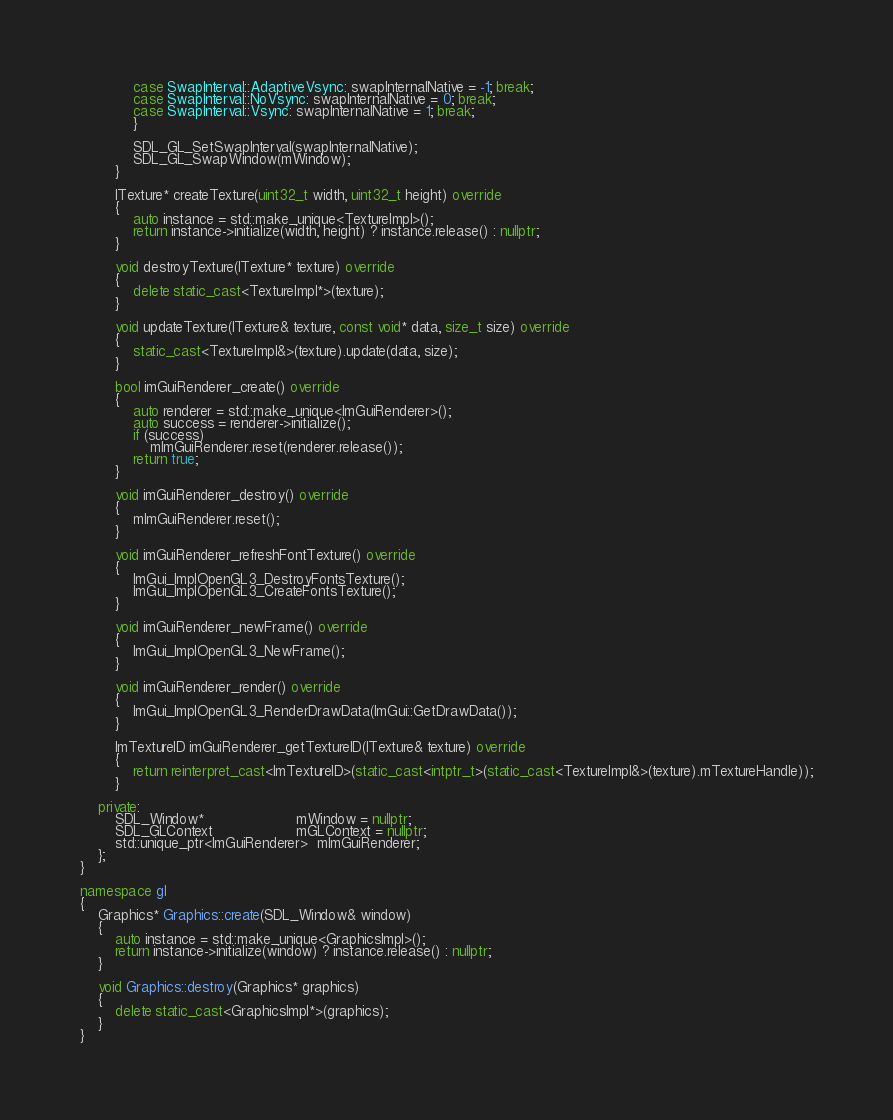<code> <loc_0><loc_0><loc_500><loc_500><_C++_>            case SwapInterval::AdaptiveVsync: swapInternalNative = -1; break;
            case SwapInterval::NoVsync: swapInternalNative = 0; break;
            case SwapInterval::Vsync: swapInternalNative = 1; break;
            }

            SDL_GL_SetSwapInterval(swapInternalNative);
            SDL_GL_SwapWindow(mWindow);
        }

        ITexture* createTexture(uint32_t width, uint32_t height) override
        {
            auto instance = std::make_unique<TextureImpl>();
            return instance->initialize(width, height) ? instance.release() : nullptr;
        }

        void destroyTexture(ITexture* texture) override
        {
            delete static_cast<TextureImpl*>(texture);
        }

        void updateTexture(ITexture& texture, const void* data, size_t size) override
        {
            static_cast<TextureImpl&>(texture).update(data, size);
        }

        bool imGuiRenderer_create() override
        {
            auto renderer = std::make_unique<ImGuiRenderer>();
            auto success = renderer->initialize();
            if (success)
                mImGuiRenderer.reset(renderer.release());
            return true;
        }

        void imGuiRenderer_destroy() override
        {
            mImGuiRenderer.reset();
        }

        void imGuiRenderer_refreshFontTexture() override
        {
            ImGui_ImplOpenGL3_DestroyFontsTexture();
            ImGui_ImplOpenGL3_CreateFontsTexture();
        }

        void imGuiRenderer_newFrame() override
        {
            ImGui_ImplOpenGL3_NewFrame();
        }

        void imGuiRenderer_render() override
        {
            ImGui_ImplOpenGL3_RenderDrawData(ImGui::GetDrawData());
        }

        ImTextureID imGuiRenderer_getTextureID(ITexture& texture) override
        {
            return reinterpret_cast<ImTextureID>(static_cast<intptr_t>(static_cast<TextureImpl&>(texture).mTextureHandle));
        }

    private:
        SDL_Window*                     mWindow = nullptr;
        SDL_GLContext                   mGLContext = nullptr;
        std::unique_ptr<ImGuiRenderer>  mImGuiRenderer;
    };
}

namespace gl
{
    Graphics* Graphics::create(SDL_Window& window)
    {
        auto instance = std::make_unique<GraphicsImpl>();
        return instance->initialize(window) ? instance.release() : nullptr;
    }

    void Graphics::destroy(Graphics* graphics)
    {
        delete static_cast<GraphicsImpl*>(graphics);
    }
}
</code> 